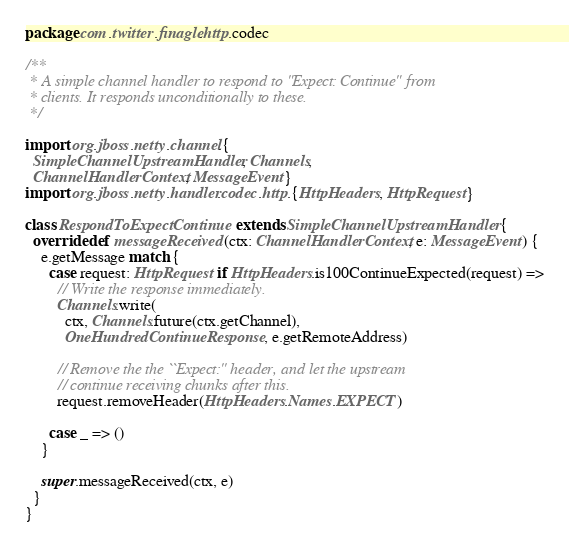<code> <loc_0><loc_0><loc_500><loc_500><_Scala_>package com.twitter.finagle.http.codec

/**
 * A simple channel handler to respond to "Expect: Continue" from
 * clients. It responds unconditionally to these.
 */

import org.jboss.netty.channel.{
  SimpleChannelUpstreamHandler, Channels,
  ChannelHandlerContext, MessageEvent}
import org.jboss.netty.handler.codec.http.{HttpHeaders, HttpRequest}

class RespondToExpectContinue extends SimpleChannelUpstreamHandler {
  override def messageReceived(ctx: ChannelHandlerContext, e: MessageEvent) {
    e.getMessage match {
      case request: HttpRequest if HttpHeaders.is100ContinueExpected(request) =>
        // Write the response immediately.
        Channels.write(
          ctx, Channels.future(ctx.getChannel),
          OneHundredContinueResponse, e.getRemoteAddress)

        // Remove the the ``Expect:'' header, and let the upstream
        // continue receiving chunks after this.
        request.removeHeader(HttpHeaders.Names.EXPECT)

      case _ => ()
    }

    super.messageReceived(ctx, e)
  }
}
</code> 